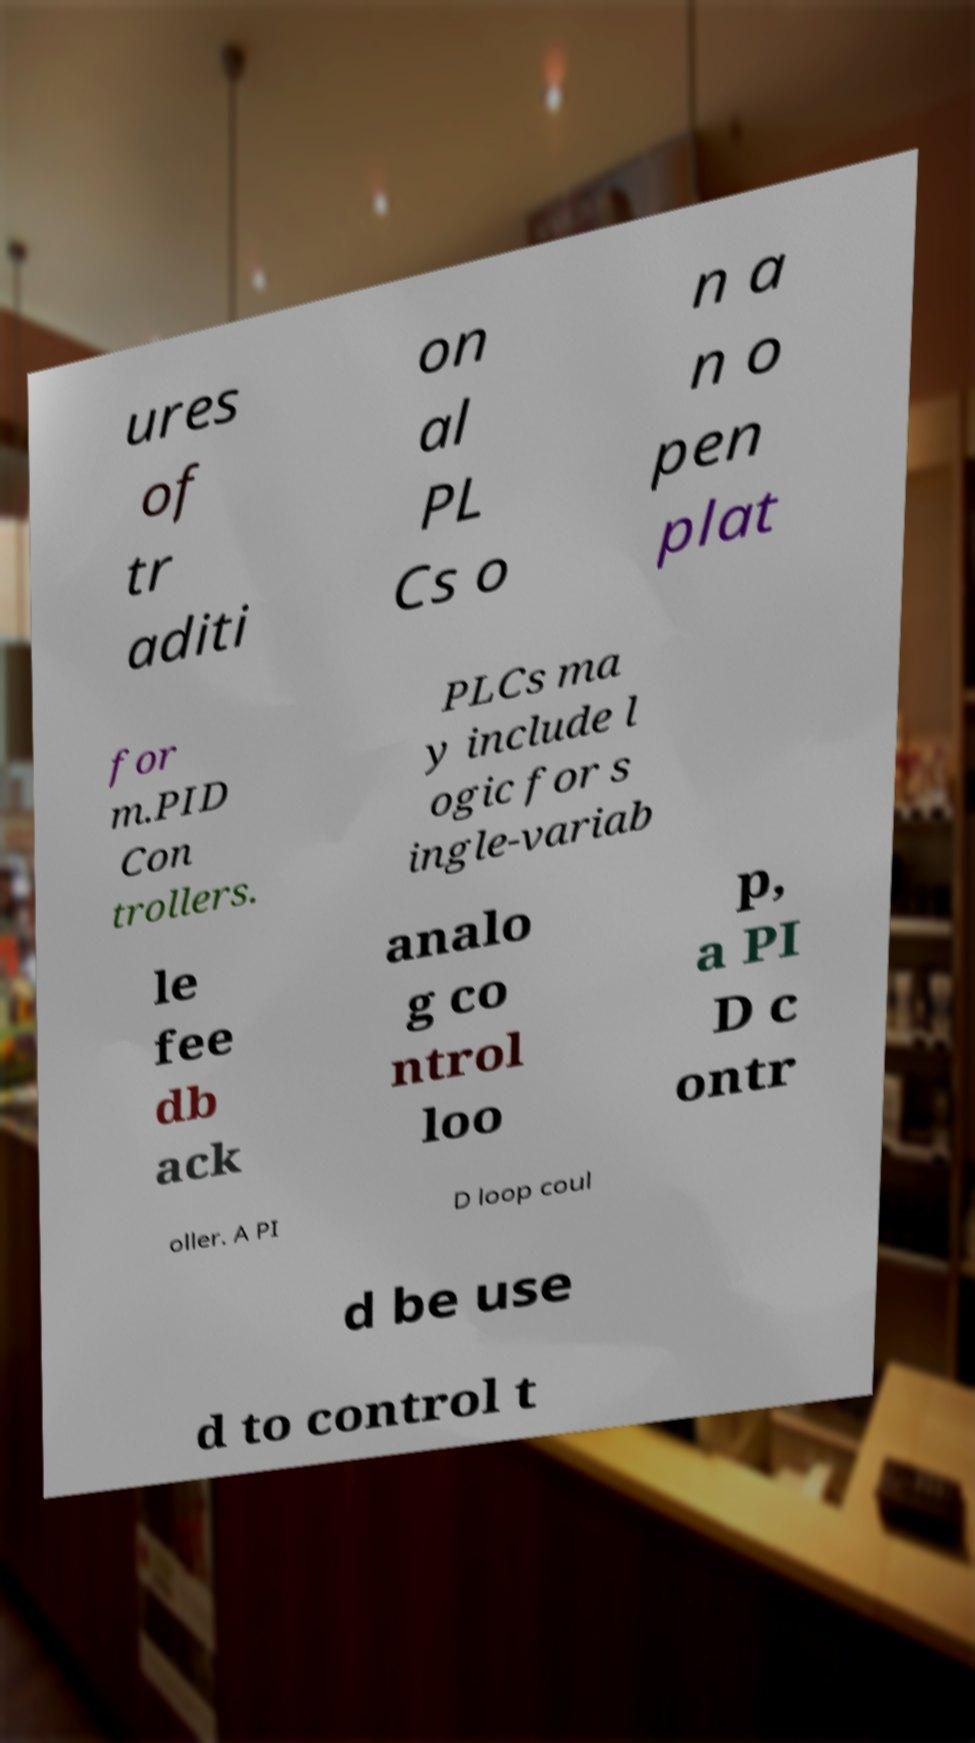Could you extract and type out the text from this image? ures of tr aditi on al PL Cs o n a n o pen plat for m.PID Con trollers. PLCs ma y include l ogic for s ingle-variab le fee db ack analo g co ntrol loo p, a PI D c ontr oller. A PI D loop coul d be use d to control t 